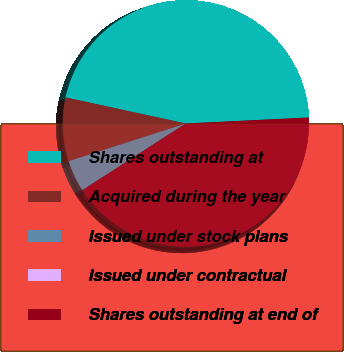Convert chart. <chart><loc_0><loc_0><loc_500><loc_500><pie_chart><fcel>Shares outstanding at<fcel>Acquired during the year<fcel>Issued under stock plans<fcel>Issued under contractual<fcel>Shares outstanding at end of<nl><fcel>45.83%<fcel>8.34%<fcel>4.17%<fcel>0.0%<fcel>41.66%<nl></chart> 